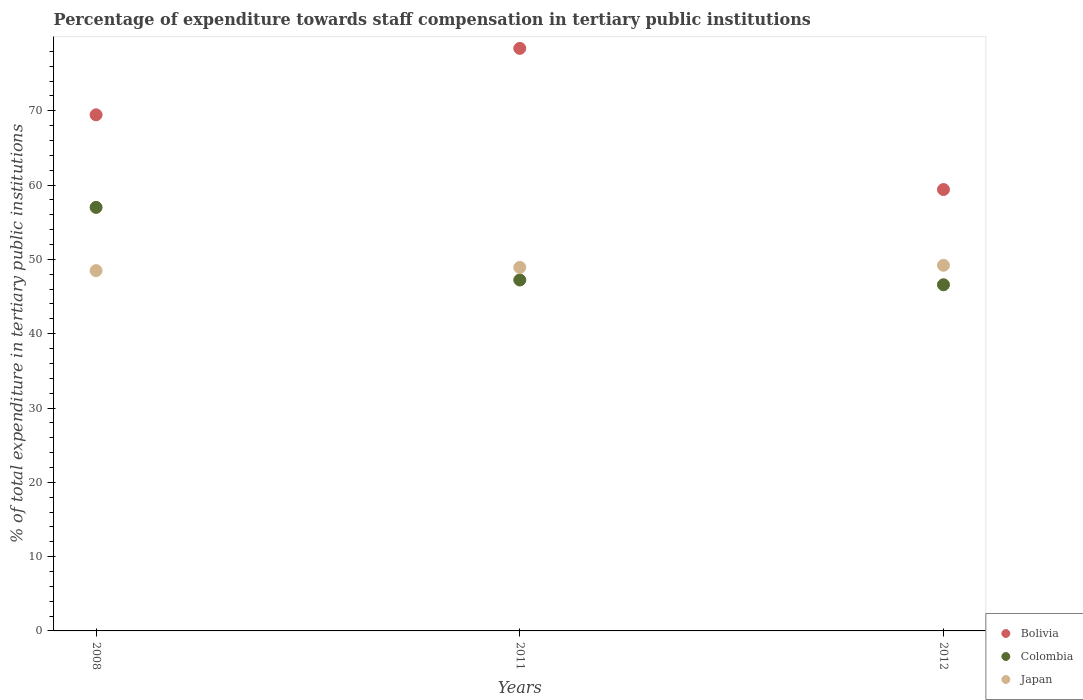Is the number of dotlines equal to the number of legend labels?
Provide a succinct answer. Yes. What is the percentage of expenditure towards staff compensation in Bolivia in 2008?
Provide a succinct answer. 69.46. Across all years, what is the maximum percentage of expenditure towards staff compensation in Colombia?
Offer a terse response. 57. Across all years, what is the minimum percentage of expenditure towards staff compensation in Colombia?
Your answer should be compact. 46.59. In which year was the percentage of expenditure towards staff compensation in Bolivia maximum?
Provide a succinct answer. 2011. In which year was the percentage of expenditure towards staff compensation in Bolivia minimum?
Provide a succinct answer. 2012. What is the total percentage of expenditure towards staff compensation in Colombia in the graph?
Provide a short and direct response. 150.81. What is the difference between the percentage of expenditure towards staff compensation in Japan in 2011 and that in 2012?
Offer a terse response. -0.28. What is the difference between the percentage of expenditure towards staff compensation in Japan in 2008 and the percentage of expenditure towards staff compensation in Colombia in 2012?
Give a very brief answer. 1.9. What is the average percentage of expenditure towards staff compensation in Japan per year?
Provide a succinct answer. 48.87. In the year 2011, what is the difference between the percentage of expenditure towards staff compensation in Bolivia and percentage of expenditure towards staff compensation in Colombia?
Provide a succinct answer. 31.17. What is the ratio of the percentage of expenditure towards staff compensation in Japan in 2008 to that in 2011?
Offer a very short reply. 0.99. Is the difference between the percentage of expenditure towards staff compensation in Bolivia in 2008 and 2012 greater than the difference between the percentage of expenditure towards staff compensation in Colombia in 2008 and 2012?
Offer a very short reply. No. What is the difference between the highest and the second highest percentage of expenditure towards staff compensation in Japan?
Keep it short and to the point. 0.28. What is the difference between the highest and the lowest percentage of expenditure towards staff compensation in Bolivia?
Offer a terse response. 18.99. In how many years, is the percentage of expenditure towards staff compensation in Bolivia greater than the average percentage of expenditure towards staff compensation in Bolivia taken over all years?
Keep it short and to the point. 2. Is the sum of the percentage of expenditure towards staff compensation in Colombia in 2008 and 2012 greater than the maximum percentage of expenditure towards staff compensation in Japan across all years?
Ensure brevity in your answer.  Yes. Does the percentage of expenditure towards staff compensation in Colombia monotonically increase over the years?
Make the answer very short. No. How many dotlines are there?
Your response must be concise. 3. Are the values on the major ticks of Y-axis written in scientific E-notation?
Your response must be concise. No. Does the graph contain grids?
Offer a terse response. No. How many legend labels are there?
Your response must be concise. 3. What is the title of the graph?
Ensure brevity in your answer.  Percentage of expenditure towards staff compensation in tertiary public institutions. Does "Chad" appear as one of the legend labels in the graph?
Offer a very short reply. No. What is the label or title of the X-axis?
Your answer should be very brief. Years. What is the label or title of the Y-axis?
Your response must be concise. % of total expenditure in tertiary public institutions. What is the % of total expenditure in tertiary public institutions of Bolivia in 2008?
Your response must be concise. 69.46. What is the % of total expenditure in tertiary public institutions of Colombia in 2008?
Give a very brief answer. 57. What is the % of total expenditure in tertiary public institutions of Japan in 2008?
Offer a very short reply. 48.49. What is the % of total expenditure in tertiary public institutions in Bolivia in 2011?
Your answer should be compact. 78.4. What is the % of total expenditure in tertiary public institutions in Colombia in 2011?
Keep it short and to the point. 47.23. What is the % of total expenditure in tertiary public institutions in Japan in 2011?
Provide a short and direct response. 48.92. What is the % of total expenditure in tertiary public institutions of Bolivia in 2012?
Your answer should be compact. 59.4. What is the % of total expenditure in tertiary public institutions of Colombia in 2012?
Your answer should be very brief. 46.59. What is the % of total expenditure in tertiary public institutions of Japan in 2012?
Your answer should be compact. 49.21. Across all years, what is the maximum % of total expenditure in tertiary public institutions of Bolivia?
Provide a short and direct response. 78.4. Across all years, what is the maximum % of total expenditure in tertiary public institutions of Colombia?
Give a very brief answer. 57. Across all years, what is the maximum % of total expenditure in tertiary public institutions of Japan?
Provide a short and direct response. 49.21. Across all years, what is the minimum % of total expenditure in tertiary public institutions of Bolivia?
Keep it short and to the point. 59.4. Across all years, what is the minimum % of total expenditure in tertiary public institutions in Colombia?
Your response must be concise. 46.59. Across all years, what is the minimum % of total expenditure in tertiary public institutions of Japan?
Offer a very short reply. 48.49. What is the total % of total expenditure in tertiary public institutions of Bolivia in the graph?
Make the answer very short. 207.25. What is the total % of total expenditure in tertiary public institutions in Colombia in the graph?
Provide a succinct answer. 150.81. What is the total % of total expenditure in tertiary public institutions of Japan in the graph?
Offer a terse response. 146.62. What is the difference between the % of total expenditure in tertiary public institutions in Bolivia in 2008 and that in 2011?
Your response must be concise. -8.94. What is the difference between the % of total expenditure in tertiary public institutions in Colombia in 2008 and that in 2011?
Provide a short and direct response. 9.77. What is the difference between the % of total expenditure in tertiary public institutions of Japan in 2008 and that in 2011?
Give a very brief answer. -0.44. What is the difference between the % of total expenditure in tertiary public institutions in Bolivia in 2008 and that in 2012?
Provide a succinct answer. 10.05. What is the difference between the % of total expenditure in tertiary public institutions in Colombia in 2008 and that in 2012?
Your answer should be very brief. 10.41. What is the difference between the % of total expenditure in tertiary public institutions in Japan in 2008 and that in 2012?
Keep it short and to the point. -0.72. What is the difference between the % of total expenditure in tertiary public institutions of Bolivia in 2011 and that in 2012?
Provide a short and direct response. 18.99. What is the difference between the % of total expenditure in tertiary public institutions in Colombia in 2011 and that in 2012?
Provide a short and direct response. 0.64. What is the difference between the % of total expenditure in tertiary public institutions of Japan in 2011 and that in 2012?
Give a very brief answer. -0.28. What is the difference between the % of total expenditure in tertiary public institutions of Bolivia in 2008 and the % of total expenditure in tertiary public institutions of Colombia in 2011?
Offer a terse response. 22.23. What is the difference between the % of total expenditure in tertiary public institutions in Bolivia in 2008 and the % of total expenditure in tertiary public institutions in Japan in 2011?
Provide a short and direct response. 20.53. What is the difference between the % of total expenditure in tertiary public institutions of Colombia in 2008 and the % of total expenditure in tertiary public institutions of Japan in 2011?
Give a very brief answer. 8.07. What is the difference between the % of total expenditure in tertiary public institutions of Bolivia in 2008 and the % of total expenditure in tertiary public institutions of Colombia in 2012?
Give a very brief answer. 22.87. What is the difference between the % of total expenditure in tertiary public institutions in Bolivia in 2008 and the % of total expenditure in tertiary public institutions in Japan in 2012?
Offer a very short reply. 20.25. What is the difference between the % of total expenditure in tertiary public institutions of Colombia in 2008 and the % of total expenditure in tertiary public institutions of Japan in 2012?
Give a very brief answer. 7.79. What is the difference between the % of total expenditure in tertiary public institutions of Bolivia in 2011 and the % of total expenditure in tertiary public institutions of Colombia in 2012?
Keep it short and to the point. 31.81. What is the difference between the % of total expenditure in tertiary public institutions in Bolivia in 2011 and the % of total expenditure in tertiary public institutions in Japan in 2012?
Ensure brevity in your answer.  29.19. What is the difference between the % of total expenditure in tertiary public institutions in Colombia in 2011 and the % of total expenditure in tertiary public institutions in Japan in 2012?
Make the answer very short. -1.98. What is the average % of total expenditure in tertiary public institutions of Bolivia per year?
Keep it short and to the point. 69.08. What is the average % of total expenditure in tertiary public institutions in Colombia per year?
Give a very brief answer. 50.27. What is the average % of total expenditure in tertiary public institutions of Japan per year?
Offer a very short reply. 48.87. In the year 2008, what is the difference between the % of total expenditure in tertiary public institutions in Bolivia and % of total expenditure in tertiary public institutions in Colombia?
Offer a terse response. 12.46. In the year 2008, what is the difference between the % of total expenditure in tertiary public institutions in Bolivia and % of total expenditure in tertiary public institutions in Japan?
Keep it short and to the point. 20.97. In the year 2008, what is the difference between the % of total expenditure in tertiary public institutions in Colombia and % of total expenditure in tertiary public institutions in Japan?
Offer a very short reply. 8.51. In the year 2011, what is the difference between the % of total expenditure in tertiary public institutions of Bolivia and % of total expenditure in tertiary public institutions of Colombia?
Your answer should be compact. 31.17. In the year 2011, what is the difference between the % of total expenditure in tertiary public institutions of Bolivia and % of total expenditure in tertiary public institutions of Japan?
Provide a short and direct response. 29.47. In the year 2011, what is the difference between the % of total expenditure in tertiary public institutions of Colombia and % of total expenditure in tertiary public institutions of Japan?
Make the answer very short. -1.7. In the year 2012, what is the difference between the % of total expenditure in tertiary public institutions in Bolivia and % of total expenditure in tertiary public institutions in Colombia?
Your answer should be compact. 12.82. In the year 2012, what is the difference between the % of total expenditure in tertiary public institutions in Bolivia and % of total expenditure in tertiary public institutions in Japan?
Ensure brevity in your answer.  10.2. In the year 2012, what is the difference between the % of total expenditure in tertiary public institutions in Colombia and % of total expenditure in tertiary public institutions in Japan?
Provide a short and direct response. -2.62. What is the ratio of the % of total expenditure in tertiary public institutions in Bolivia in 2008 to that in 2011?
Provide a succinct answer. 0.89. What is the ratio of the % of total expenditure in tertiary public institutions of Colombia in 2008 to that in 2011?
Keep it short and to the point. 1.21. What is the ratio of the % of total expenditure in tertiary public institutions of Bolivia in 2008 to that in 2012?
Provide a succinct answer. 1.17. What is the ratio of the % of total expenditure in tertiary public institutions of Colombia in 2008 to that in 2012?
Offer a very short reply. 1.22. What is the ratio of the % of total expenditure in tertiary public institutions of Japan in 2008 to that in 2012?
Offer a very short reply. 0.99. What is the ratio of the % of total expenditure in tertiary public institutions of Bolivia in 2011 to that in 2012?
Ensure brevity in your answer.  1.32. What is the ratio of the % of total expenditure in tertiary public institutions of Colombia in 2011 to that in 2012?
Make the answer very short. 1.01. What is the difference between the highest and the second highest % of total expenditure in tertiary public institutions of Bolivia?
Keep it short and to the point. 8.94. What is the difference between the highest and the second highest % of total expenditure in tertiary public institutions of Colombia?
Offer a terse response. 9.77. What is the difference between the highest and the second highest % of total expenditure in tertiary public institutions of Japan?
Make the answer very short. 0.28. What is the difference between the highest and the lowest % of total expenditure in tertiary public institutions in Bolivia?
Your answer should be compact. 18.99. What is the difference between the highest and the lowest % of total expenditure in tertiary public institutions of Colombia?
Your answer should be very brief. 10.41. What is the difference between the highest and the lowest % of total expenditure in tertiary public institutions in Japan?
Ensure brevity in your answer.  0.72. 